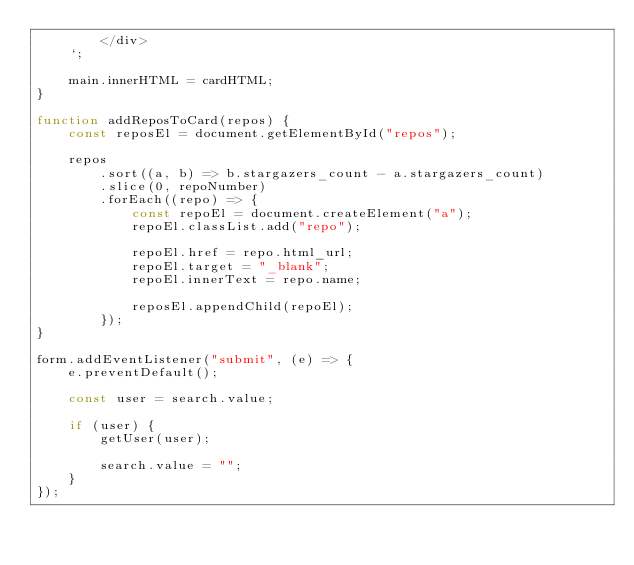<code> <loc_0><loc_0><loc_500><loc_500><_JavaScript_>        </div>
    `;

    main.innerHTML = cardHTML;
}

function addReposToCard(repos) {
    const reposEl = document.getElementById("repos");

    repos
        .sort((a, b) => b.stargazers_count - a.stargazers_count)
        .slice(0, repoNumber)
        .forEach((repo) => {
            const repoEl = document.createElement("a");
            repoEl.classList.add("repo");

            repoEl.href = repo.html_url;
            repoEl.target = "_blank";
            repoEl.innerText = repo.name;

            reposEl.appendChild(repoEl);
        });
}

form.addEventListener("submit", (e) => {
    e.preventDefault();

    const user = search.value;

    if (user) {
        getUser(user);

        search.value = "";
    }
});</code> 